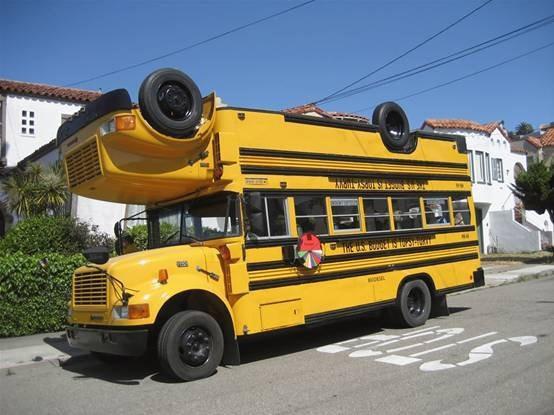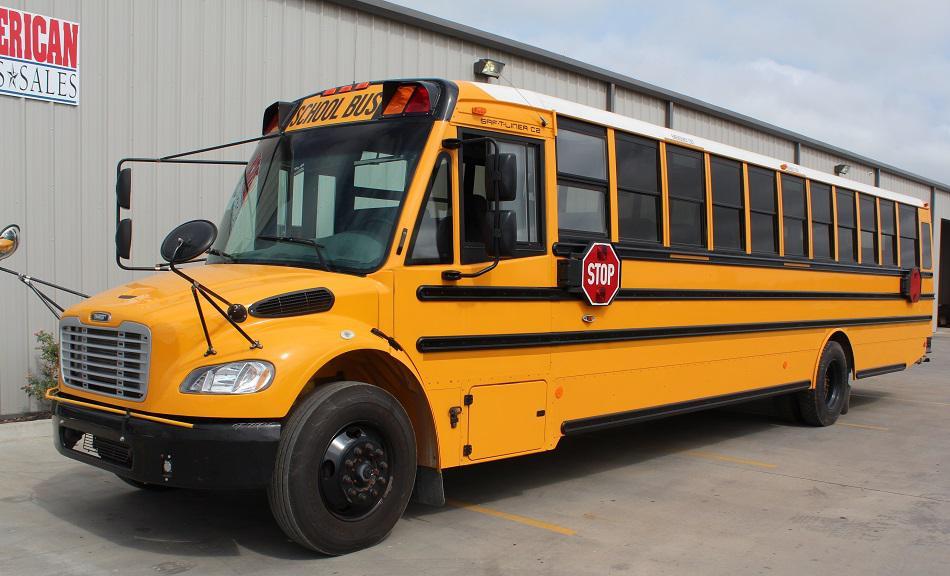The first image is the image on the left, the second image is the image on the right. For the images displayed, is the sentence "Every school bus is pointing to the left." factually correct? Answer yes or no. Yes. The first image is the image on the left, the second image is the image on the right. Assess this claim about the two images: "Each image contains one bus that has a non-flat front and is parked at a leftward angle, with the red sign on its side facing the camera.". Correct or not? Answer yes or no. Yes. 